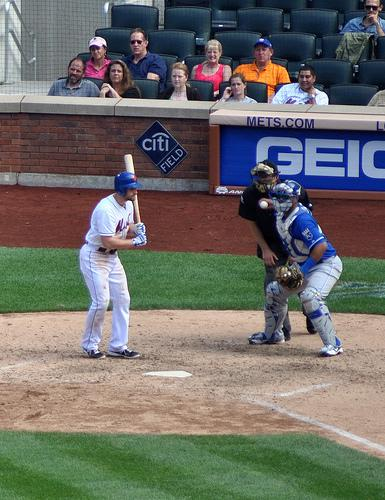Question: where was this picture taken?
Choices:
A. A soccer game.
B. A tennis court.
C. A lake.
D. A baseball field.
Answer with the letter. Answer: D Question: how many people are on the field?
Choices:
A. 3.
B. 4.
C. 5.
D. 6.
Answer with the letter. Answer: A Question: where do you see "METS.COM"?
Choices:
A. On the magnet.
B. On the backwall.
C. On the sign.
D. On the computer screen.
Answer with the letter. Answer: B 